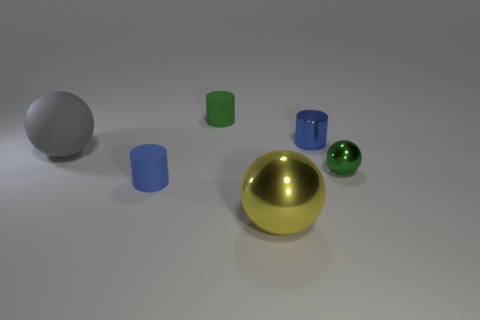What material is the object that is the same size as the yellow sphere?
Offer a terse response. Rubber. Is there a purple matte cylinder that has the same size as the green rubber object?
Ensure brevity in your answer.  No. There is a small metallic cylinder that is to the right of the yellow ball; what color is it?
Make the answer very short. Blue. There is a blue cylinder right of the yellow thing; are there any blue things behind it?
Your response must be concise. No. How many other objects are the same color as the metallic cylinder?
Your answer should be very brief. 1. Do the rubber cylinder that is behind the gray rubber thing and the metal sphere that is in front of the green ball have the same size?
Ensure brevity in your answer.  No. What is the size of the ball on the left side of the blue cylinder in front of the big gray sphere?
Provide a short and direct response. Large. There is a cylinder that is to the left of the tiny shiny cylinder and behind the green metallic ball; what material is it?
Provide a short and direct response. Rubber. What color is the large rubber sphere?
Give a very brief answer. Gray. Are there any other things that are made of the same material as the large gray sphere?
Offer a very short reply. Yes. 